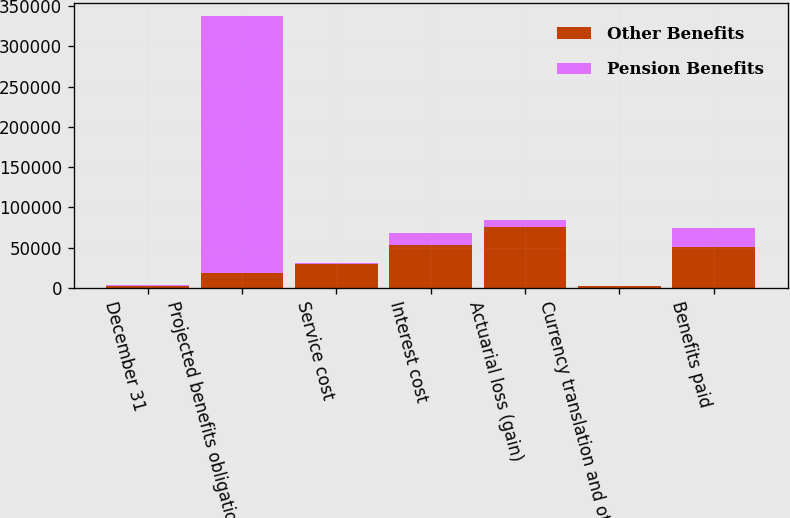Convert chart. <chart><loc_0><loc_0><loc_500><loc_500><stacked_bar_chart><ecel><fcel>December 31<fcel>Projected benefits obligation<fcel>Service cost<fcel>Interest cost<fcel>Actuarial loss (gain)<fcel>Currency translation and other<fcel>Benefits paid<nl><fcel>Other Benefits<fcel>2011<fcel>18888.5<fcel>30059<fcel>52960<fcel>75790<fcel>2052<fcel>51179<nl><fcel>Pension Benefits<fcel>2011<fcel>318536<fcel>1333<fcel>14967<fcel>8115<fcel>332<fcel>22810<nl></chart> 